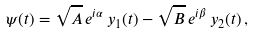<formula> <loc_0><loc_0><loc_500><loc_500>\psi ( t ) = \sqrt { A } \, e ^ { i \alpha } \, y _ { 1 } ( t ) - \sqrt { B } \, e ^ { i \beta } \, y _ { 2 } ( t ) \, ,</formula> 